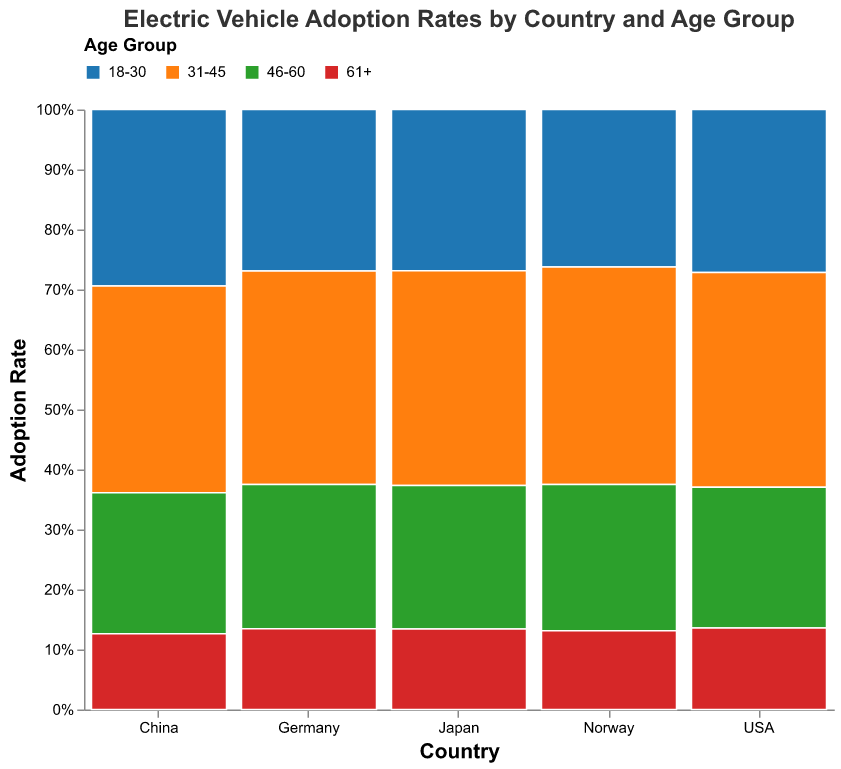What is the title of the figure? The title is located at the top of the plot. It reads: "Electric Vehicle Adoption Rates by Country and Age Group."
Answer: Electric Vehicle Adoption Rates by Country and Age Group Which country has the highest electric vehicle adoption rate for the 31-45 age group? Look at the section of the plot corresponding to the 31-45 age group and compare the heights of the colored bars for each country. Norway has the highest bar.
Answer: Norway What percentage of electric vehicle adoption in Japan comes from the 18-30 age group? Hovering over Japan's section of the plot will show the tooltip for each age group. The tooltip indicates the percentage for the 18-30 age group.
Answer: 18% Which country has the highest adoption rate for the 61+ age group? Compare the relative height of each colored section for the 61+ age group among all countries. Norway has the highest adoption rate in this age group.
Answer: Norway How does the adoption rate of electric vehicles in the 18-30 age group in Germany compare to that in the USA? Look at the sections for the 18-30 age group in both Germany and USA, and compare the heights of these sections. Germany's section is higher than the USA's section.
Answer: Germany's adoption rate is higher than the USA's What is the overall trend of electric vehicle adoption with respect to age in Norway? Observe the heights of the sections within the Norwegian data. Adoption rates peak in the 31-45 age group, then decrease as age increases.
Answer: Peaks at 31-45, decreases with age For which age group is the percentage of electric vehicle adoption lowest in China? Compare the heights of the sections within the Chinese data. The 61+ age group has the lowest section.
Answer: 61+ Calculate the combined adoption rate for 46-60 and 61+ age groups in Japan. Sum the heights of the sections for the 46-60 and 61+ age groups in Japan. The 46-60 age group has a rate of 16% and the 61+ age group has a rate of 9%, resulting in a combined rate of 25%.
Answer: 25% Which countries show a higher adoption rate for the 31-45 group compared to the 18-30 group? Compare the heights of the sections for the 31-45 group and the 18-30 group for each country. Norway, China, USA, Germany, and Japan all show higher adoption rates in the 31-45 group compared to the 18-30 group.
Answer: Norway, China, USA, Germany, Japan Identify the country with the most uniform adoption rates across all age groups. Assess the height of sections within each country. Lower variability indicates more uniform adoption. Norway shows relatively uniform adoption rates across age groups.
Answer: Norway 